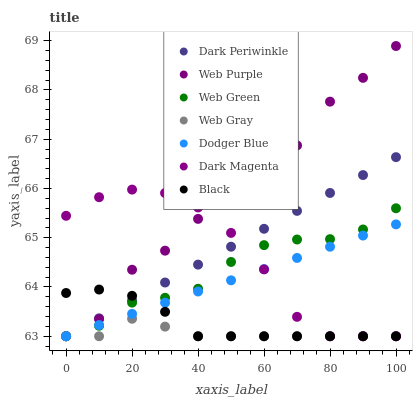Does Web Gray have the minimum area under the curve?
Answer yes or no. Yes. Does Web Purple have the maximum area under the curve?
Answer yes or no. Yes. Does Dark Magenta have the minimum area under the curve?
Answer yes or no. No. Does Dark Magenta have the maximum area under the curve?
Answer yes or no. No. Is Dodger Blue the smoothest?
Answer yes or no. Yes. Is Web Purple the roughest?
Answer yes or no. Yes. Is Dark Magenta the smoothest?
Answer yes or no. No. Is Dark Magenta the roughest?
Answer yes or no. No. Does Web Gray have the lowest value?
Answer yes or no. Yes. Does Web Purple have the highest value?
Answer yes or no. Yes. Does Dark Magenta have the highest value?
Answer yes or no. No. Does Dark Magenta intersect Web Gray?
Answer yes or no. Yes. Is Dark Magenta less than Web Gray?
Answer yes or no. No. Is Dark Magenta greater than Web Gray?
Answer yes or no. No. 